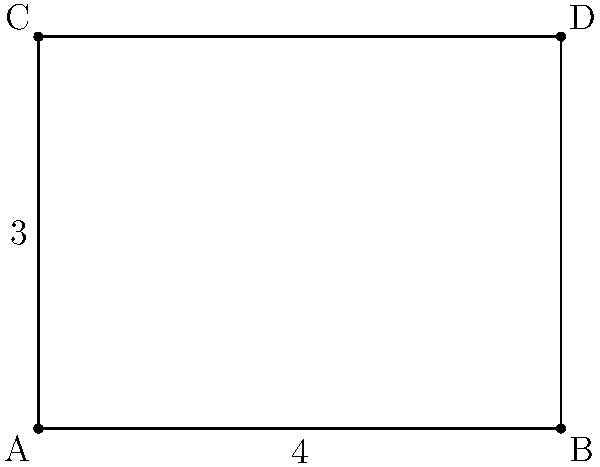In your research on geometric principles for a journalism article, you come across the following figure. Two parallel lines are connected by perpendicular line segments. If the length of one perpendicular segment is 3 units and the distance between the perpendicular segments is 4 units, how would you determine the length of the other perpendicular segment? Explain your reasoning and provide the answer. To determine the length of the other perpendicular segment, we can use the properties of parallel lines and rectangles:

1. Recognize that the figure forms a rectangle ABCD.
2. In a rectangle, opposite sides are parallel and equal in length.
3. The given perpendicular segment (AC) has a length of 3 units.
4. Since opposite sides of a rectangle are equal, the other perpendicular segment (BD) must also be 3 units long.

This problem demonstrates that when two parallel lines are connected by perpendicular segments, those segments are equal in length, regardless of where they are positioned along the parallel lines. This principle is crucial in various journalistic contexts, such as architectural reporting or explaining geometric concepts to a general audience.
Answer: 3 units 